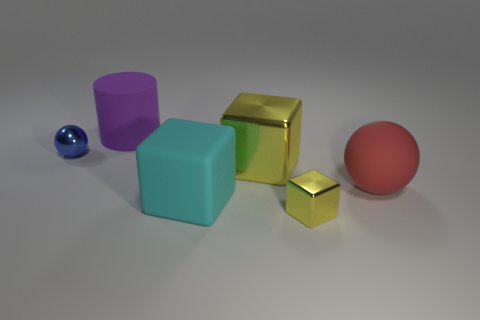Is the size of the cyan rubber block the same as the shiny thing that is in front of the cyan rubber cube?
Give a very brief answer. No. There is a sphere that is on the right side of the big purple object; are there any yellow metallic cubes that are behind it?
Make the answer very short. Yes. There is a thing that is both right of the large yellow object and behind the tiny yellow block; what is its material?
Offer a very short reply. Rubber. What is the color of the metal cube in front of the big matte object to the right of the big matte object that is in front of the rubber sphere?
Keep it short and to the point. Yellow. There is a ball that is the same size as the purple object; what is its color?
Provide a short and direct response. Red. There is a rubber block; does it have the same color as the small metallic thing that is on the left side of the purple cylinder?
Your response must be concise. No. There is a sphere in front of the small shiny object left of the small yellow object; what is its material?
Keep it short and to the point. Rubber. What number of objects are behind the tiny yellow metal cube and left of the big sphere?
Provide a succinct answer. 4. What number of other things are the same size as the red rubber ball?
Your answer should be compact. 3. Does the big object that is behind the blue ball have the same shape as the tiny metallic object in front of the shiny sphere?
Ensure brevity in your answer.  No. 